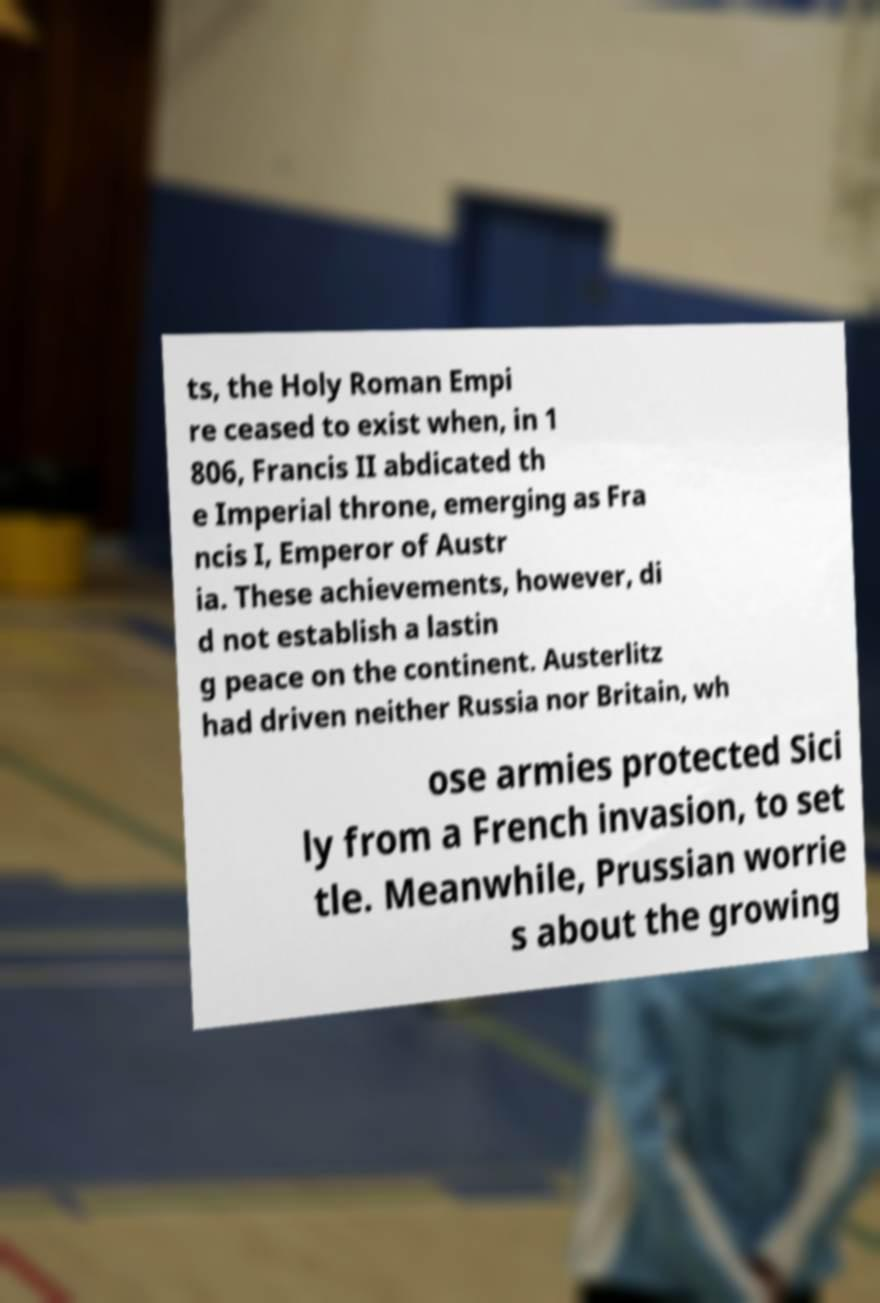Please identify and transcribe the text found in this image. ts, the Holy Roman Empi re ceased to exist when, in 1 806, Francis II abdicated th e Imperial throne, emerging as Fra ncis I, Emperor of Austr ia. These achievements, however, di d not establish a lastin g peace on the continent. Austerlitz had driven neither Russia nor Britain, wh ose armies protected Sici ly from a French invasion, to set tle. Meanwhile, Prussian worrie s about the growing 